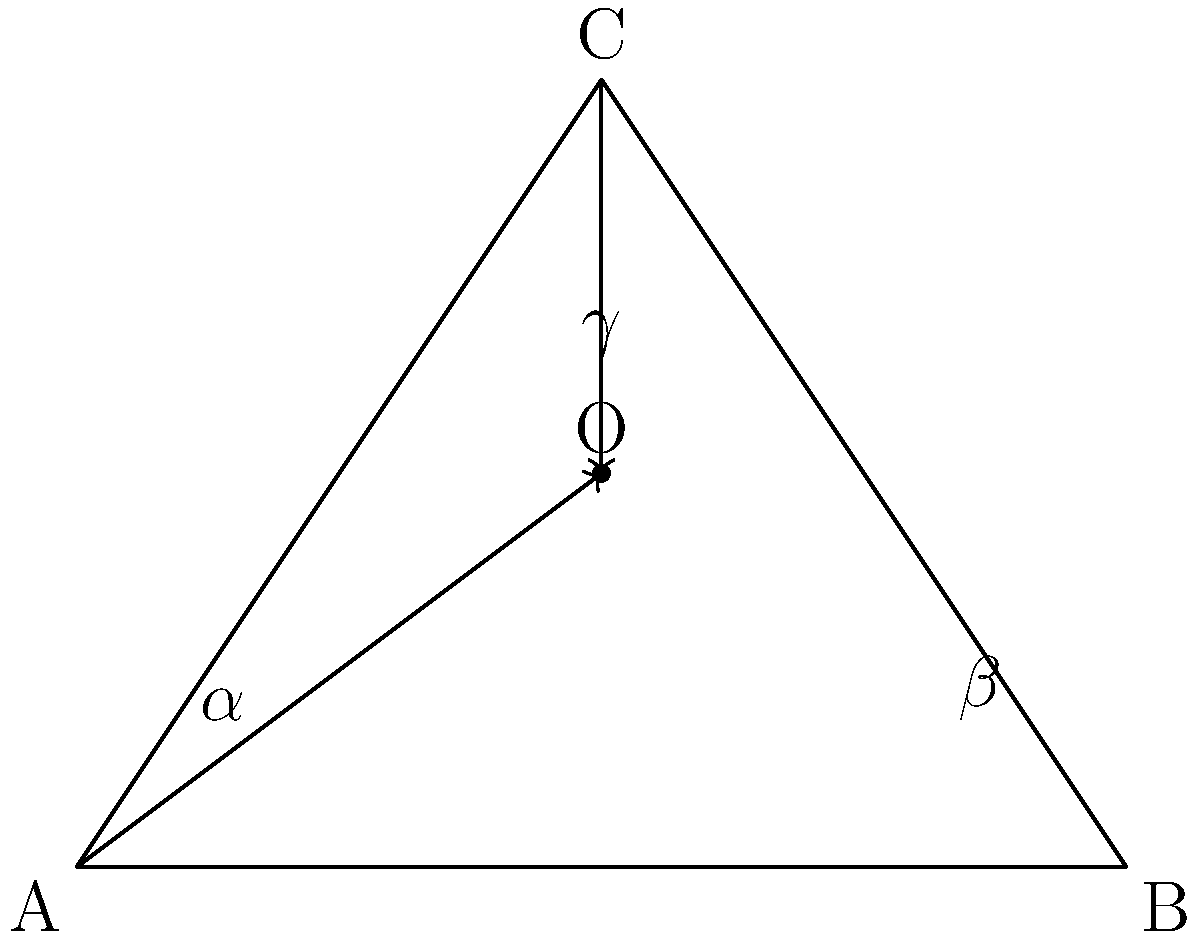In a beautiful stained glass window of our church, light rays pass through three points forming a triangle ABC. Two light rays intersect at point O inside the triangle. If the angles formed by these rays at point O are $\alpha$, $\beta$, and $\gamma$ as shown in the figure, what is the sum of these angles? How does this relate to the Holy Trinity? Let's approach this step-by-step:

1) In any triangle, the sum of interior angles is always 180°. This is a fundamental property in Euclidean geometry.

2) The point O inside the triangle divides it into three smaller triangles.

3) Each of these smaller triangles contains one of the angles $\alpha$, $\beta$, or $\gamma$ at point O.

4) The other two angles in each of these smaller triangles are parts of the original triangle's interior angles.

5) Since the three smaller triangles completely fill the original triangle, the sum of all their angles must equal the sum of the angles in the original triangle.

6) We know that the sum of angles in the original triangle is 180°.

7) The sum of angles in the three smaller triangles is:
   $(\alpha + \text{two partial angles}) + (\beta + \text{two partial angles}) + (\gamma + \text{two partial angles}) = 180°$

8) Simplifying, we get:
   $\alpha + \beta + \gamma + (\text{all partial angles}) = 180°$

9) But the sum of all partial angles is just the three angles of the original triangle, which is 180°.

10) Therefore:
    $\alpha + \beta + \gamma + 180° = 180°$

11) Subtracting 180° from both sides:
    $\alpha + \beta + \gamma = 180° - 180° = 0°$

This result, where three distinct elements ($\alpha$, $\beta$, $\gamma$) sum to form a perfect whole (360°), can be seen as a beautiful representation of the Holy Trinity: three distinct persons (Father, Son, and Holy Spirit) in one God.
Answer: $360°$; symbolizes the unity of the Holy Trinity 